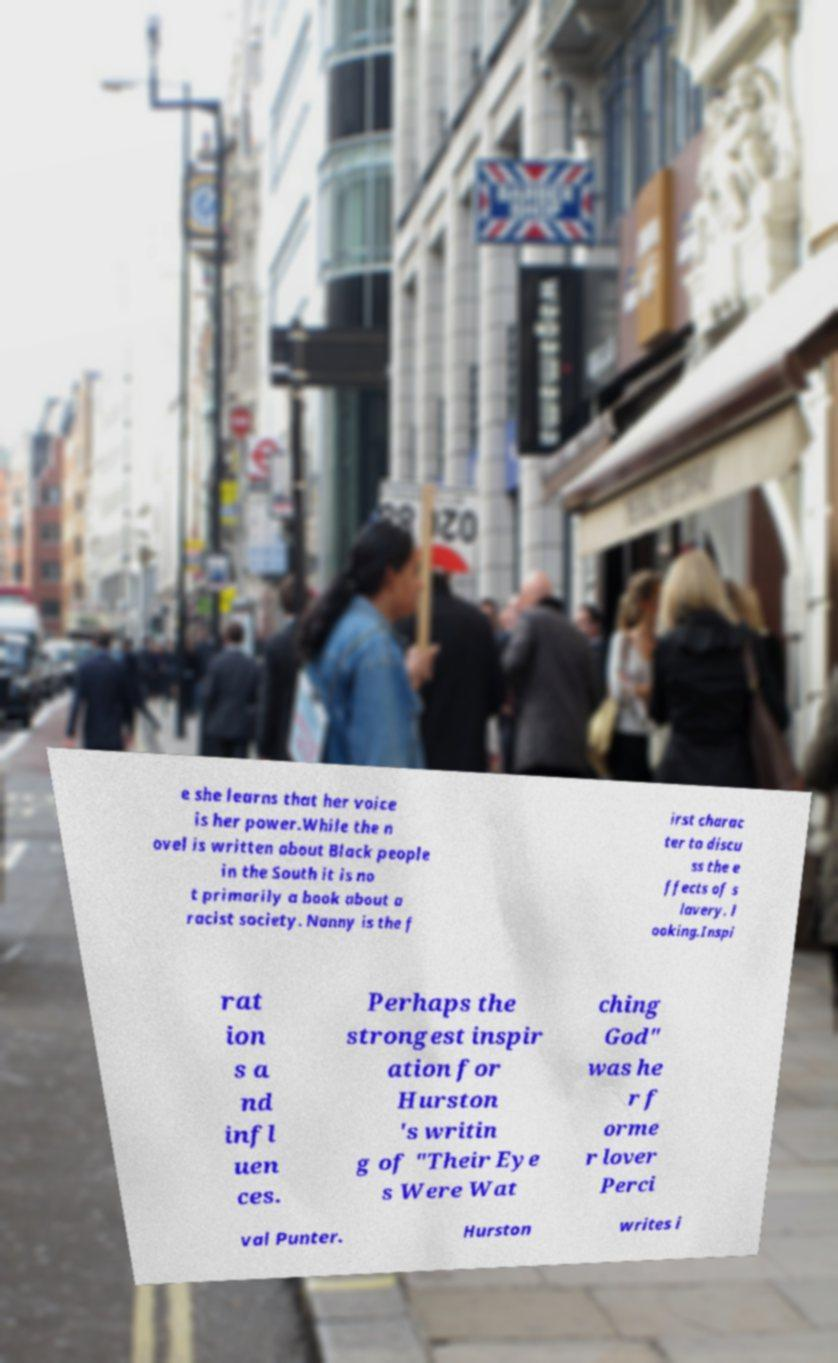I need the written content from this picture converted into text. Can you do that? e she learns that her voice is her power.While the n ovel is written about Black people in the South it is no t primarily a book about a racist society. Nanny is the f irst charac ter to discu ss the e ffects of s lavery. l ooking.Inspi rat ion s a nd infl uen ces. Perhaps the strongest inspir ation for Hurston 's writin g of "Their Eye s Were Wat ching God" was he r f orme r lover Perci val Punter. Hurston writes i 